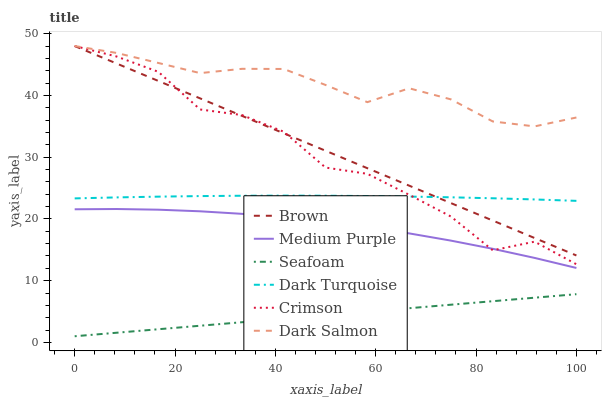Does Seafoam have the minimum area under the curve?
Answer yes or no. Yes. Does Dark Salmon have the maximum area under the curve?
Answer yes or no. Yes. Does Dark Turquoise have the minimum area under the curve?
Answer yes or no. No. Does Dark Turquoise have the maximum area under the curve?
Answer yes or no. No. Is Seafoam the smoothest?
Answer yes or no. Yes. Is Crimson the roughest?
Answer yes or no. Yes. Is Dark Turquoise the smoothest?
Answer yes or no. No. Is Dark Turquoise the roughest?
Answer yes or no. No. Does Dark Turquoise have the lowest value?
Answer yes or no. No. Does Crimson have the highest value?
Answer yes or no. Yes. Does Dark Turquoise have the highest value?
Answer yes or no. No. Is Seafoam less than Dark Turquoise?
Answer yes or no. Yes. Is Crimson greater than Seafoam?
Answer yes or no. Yes. Does Crimson intersect Dark Salmon?
Answer yes or no. Yes. Is Crimson less than Dark Salmon?
Answer yes or no. No. Is Crimson greater than Dark Salmon?
Answer yes or no. No. Does Seafoam intersect Dark Turquoise?
Answer yes or no. No. 